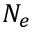<formula> <loc_0><loc_0><loc_500><loc_500>N _ { e }</formula> 